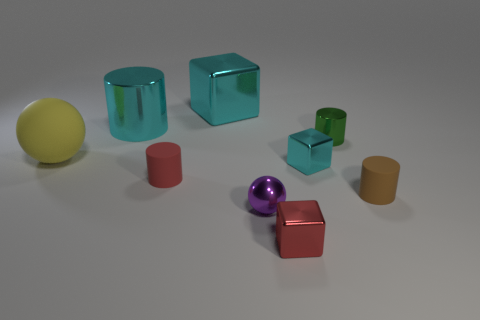What material is the small object that is left of the cyan metallic object behind the large cylinder?
Make the answer very short. Rubber. Do the cyan cylinder and the red shiny cube have the same size?
Ensure brevity in your answer.  No. What number of objects are tiny shiny objects in front of the purple thing or tiny green cylinders?
Your answer should be compact. 2. There is a cyan thing on the right side of the red thing in front of the red matte thing; what shape is it?
Ensure brevity in your answer.  Cube. There is a purple thing; is it the same size as the cube that is behind the large matte thing?
Your answer should be compact. No. What is the block that is in front of the brown matte cylinder made of?
Offer a terse response. Metal. How many objects are both in front of the cyan cylinder and on the left side of the small brown object?
Ensure brevity in your answer.  6. There is a green thing that is the same size as the red matte cylinder; what is its material?
Make the answer very short. Metal. Is the size of the shiny thing in front of the tiny purple thing the same as the yellow thing behind the purple metal thing?
Your response must be concise. No. Are there any large cylinders on the right side of the large metallic block?
Your response must be concise. No. 